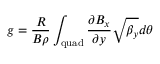Convert formula to latex. <formula><loc_0><loc_0><loc_500><loc_500>g = \frac { R } { B \rho } \int _ { q u a d } \frac { \partial B _ { x } } { \partial y } \sqrt { \beta _ { y } } d \theta</formula> 